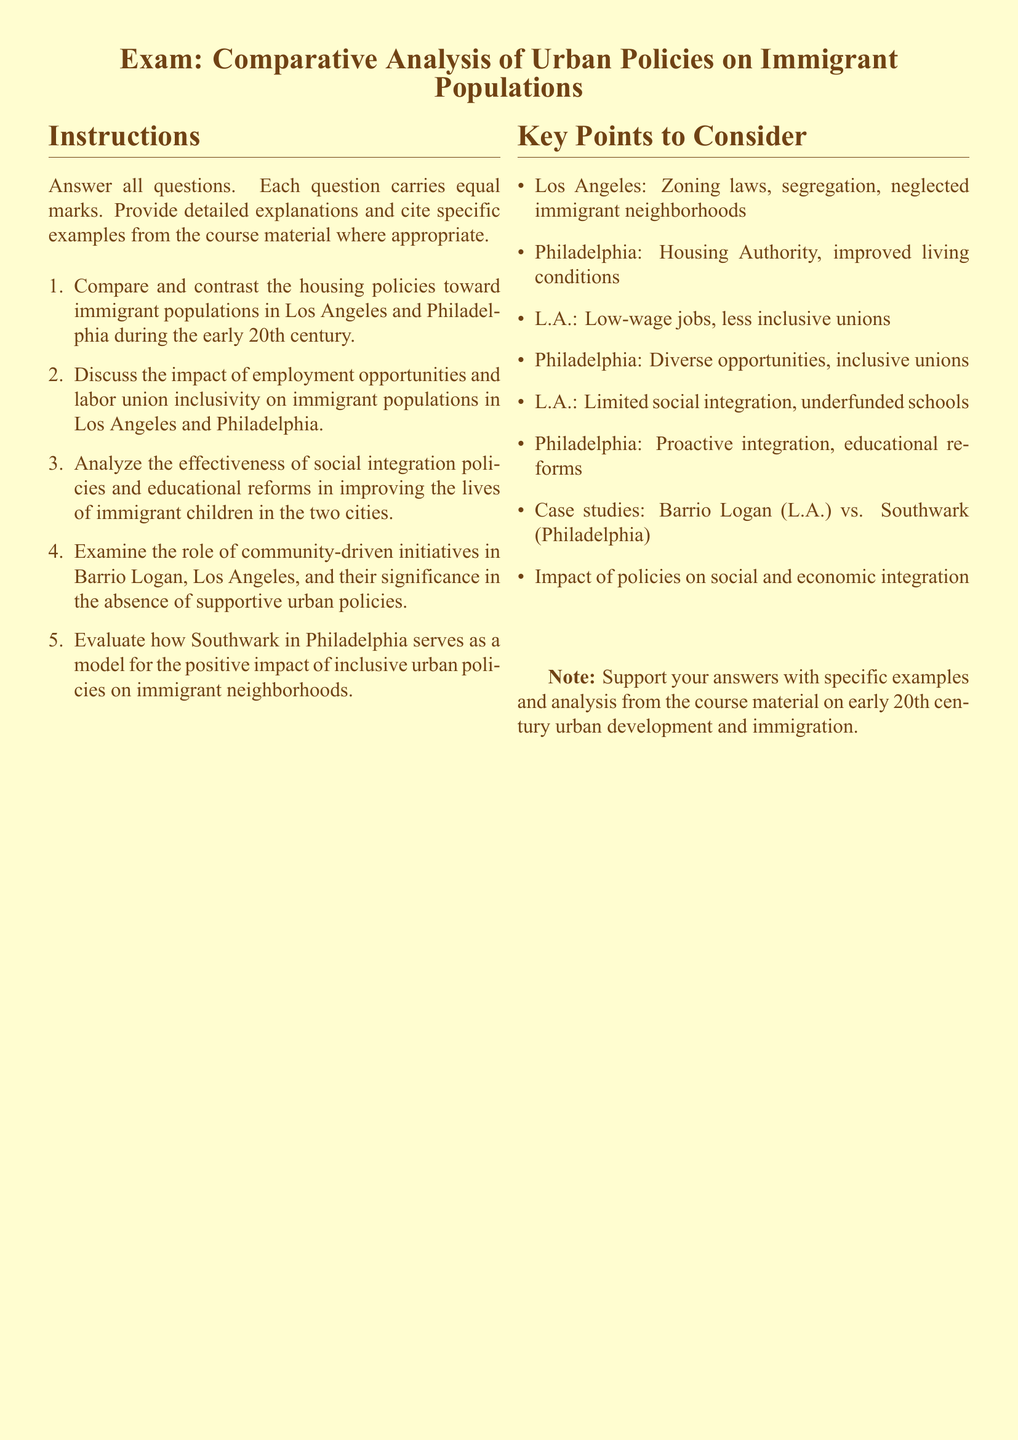What is the title of the exam? The title of the exam is explicitly stated at the beginning of the document, highlighting the subject focus.
Answer: Comparative Analysis of Urban Policies on Immigrant Populations How many sections are in the exam? The document outlines two main sections: instructions and key points to consider.
Answer: Two In which city is Barrio Logan located? The document mentions Barrio Logan as a specific case study tied to urban policies regarding immigrants in Los Angeles.
Answer: Los Angeles What urban area is cited as a model for positive policies in the document? The document specifically identifies Southwark in Philadelphia as a model for inclusive urban policies.
Answer: Southwark What type of policies are discussed in relation to educational reforms? The document categorizes policies to enhance social integration and educational improvements for immigrant children.
Answer: Social integration What is a notable challenge faced by immigrants in Los Angeles according to the document? The document references limited social integration, which underscores difficulties faced by the immigrant population in Los Angeles.
Answer: Limited social integration What is emphasized about Philadelphia's labor unions in the document? The document highlights inclusivity of labor unions in Philadelphia as a significant aspect affecting immigrant employment opportunities.
Answer: Inclusive unions What are the housing policies in Los Angeles described as? The document describes the housing policies in Los Angeles as more focused on zoning laws and segregation, indicating neglect of immigrant neighborhoods.
Answer: Neglected immigrant neighborhoods 